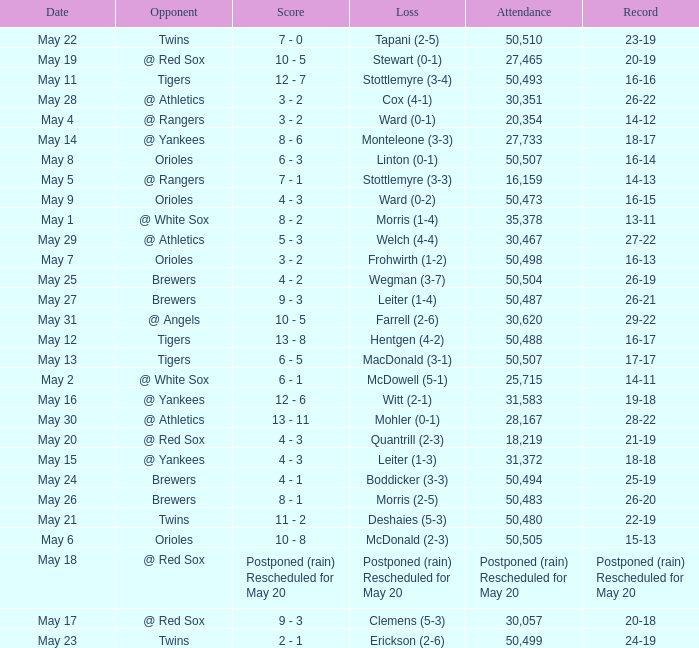What team did they lose to when they had a 28-22 record? Mohler (0-1). 